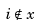<formula> <loc_0><loc_0><loc_500><loc_500>i \notin x</formula> 